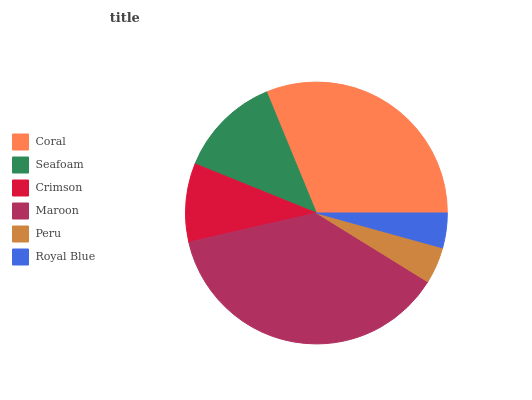Is Royal Blue the minimum?
Answer yes or no. Yes. Is Maroon the maximum?
Answer yes or no. Yes. Is Seafoam the minimum?
Answer yes or no. No. Is Seafoam the maximum?
Answer yes or no. No. Is Coral greater than Seafoam?
Answer yes or no. Yes. Is Seafoam less than Coral?
Answer yes or no. Yes. Is Seafoam greater than Coral?
Answer yes or no. No. Is Coral less than Seafoam?
Answer yes or no. No. Is Seafoam the high median?
Answer yes or no. Yes. Is Crimson the low median?
Answer yes or no. Yes. Is Coral the high median?
Answer yes or no. No. Is Coral the low median?
Answer yes or no. No. 